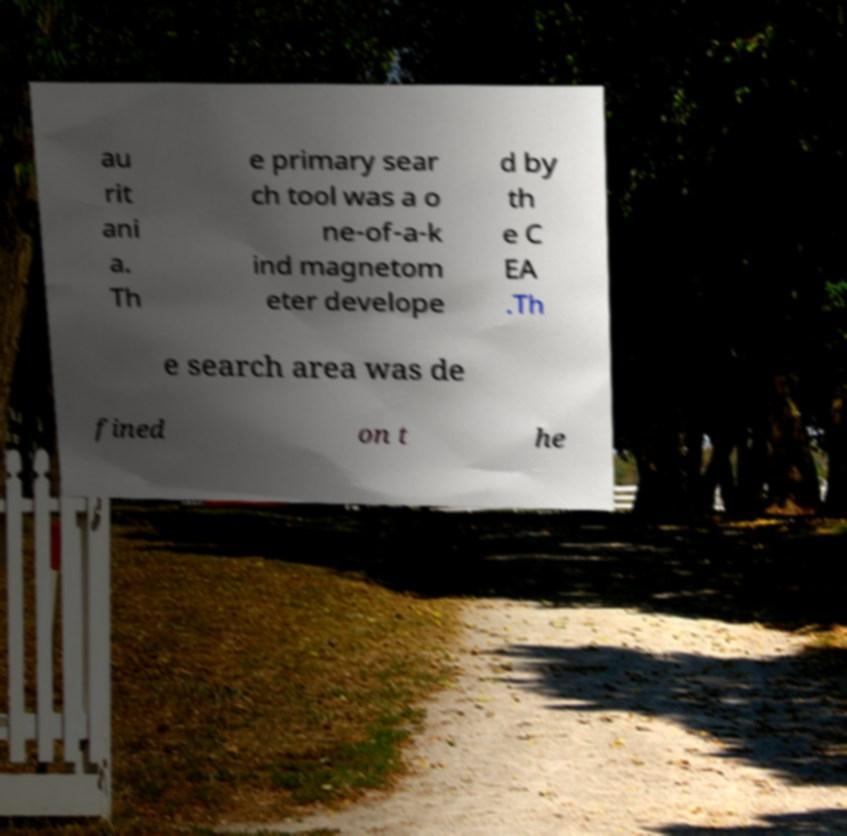Can you accurately transcribe the text from the provided image for me? au rit ani a. Th e primary sear ch tool was a o ne-of-a-k ind magnetom eter develope d by th e C EA .Th e search area was de fined on t he 